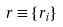<formula> <loc_0><loc_0><loc_500><loc_500>r \equiv \{ r _ { i } \}</formula> 